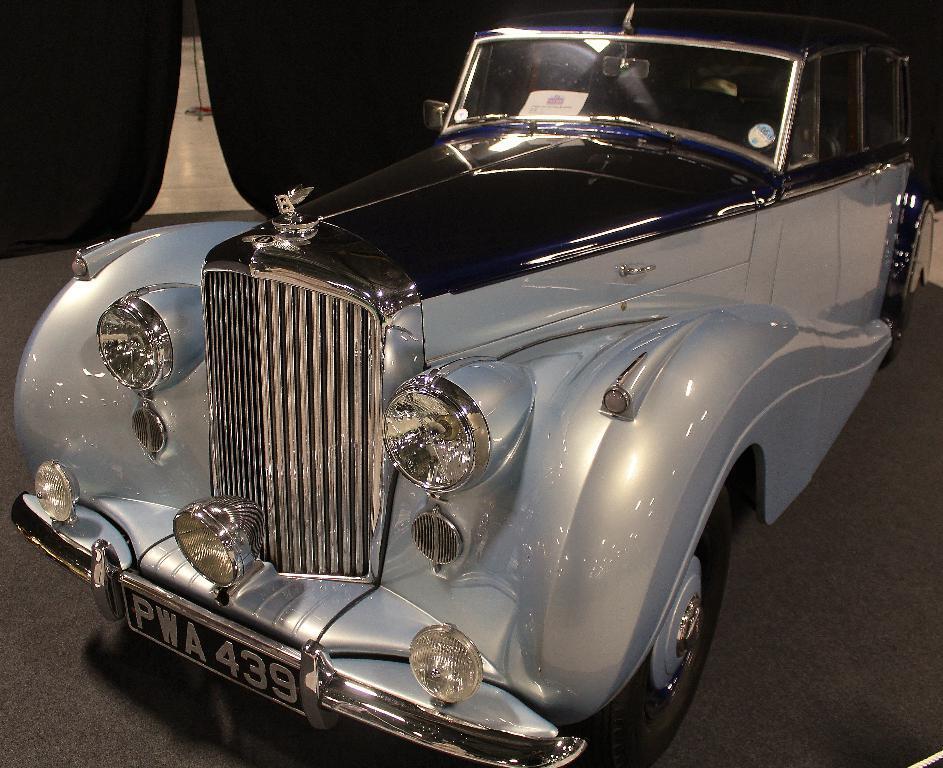Can you describe this image briefly? In this image in the center there is a car, and there is a black background and some object. At the bottom there is floor. 